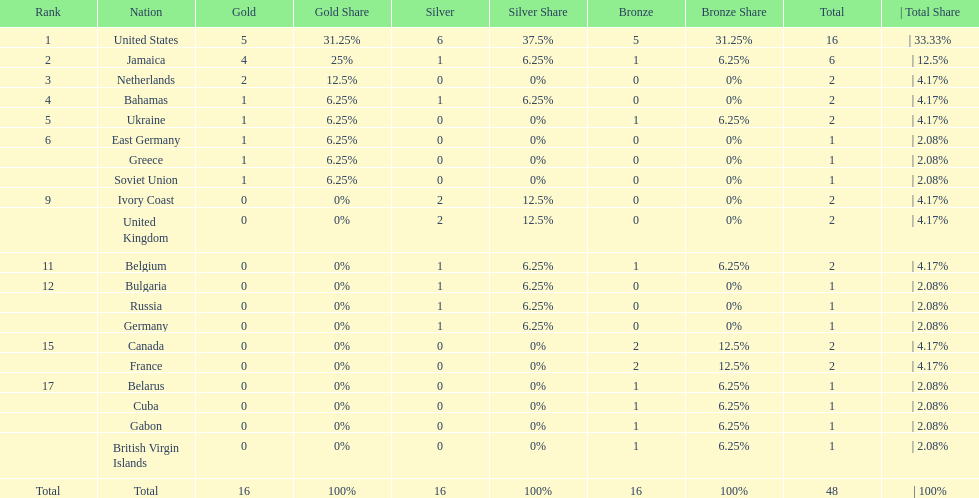What number of nations received 1 medal? 10. 